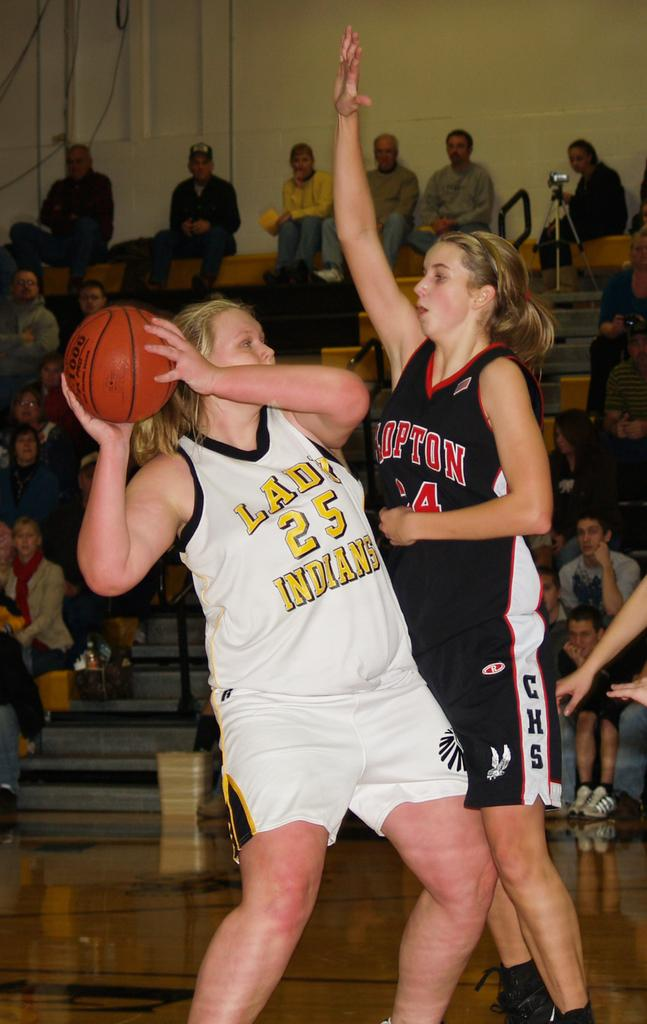<image>
Render a clear and concise summary of the photo. A Lady Indians player attempts to throw the ball past an opponent. 